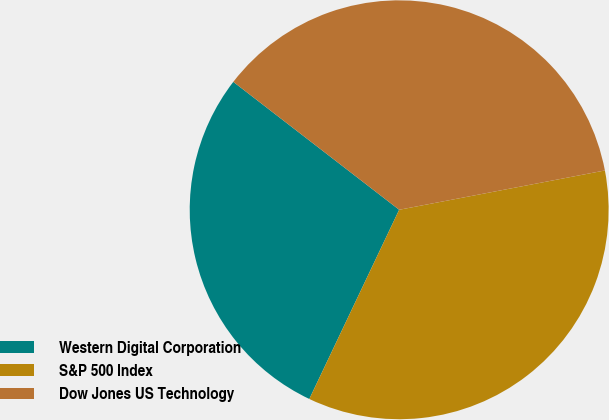Convert chart. <chart><loc_0><loc_0><loc_500><loc_500><pie_chart><fcel>Western Digital Corporation<fcel>S&P 500 Index<fcel>Dow Jones US Technology<nl><fcel>28.4%<fcel>35.06%<fcel>36.54%<nl></chart> 